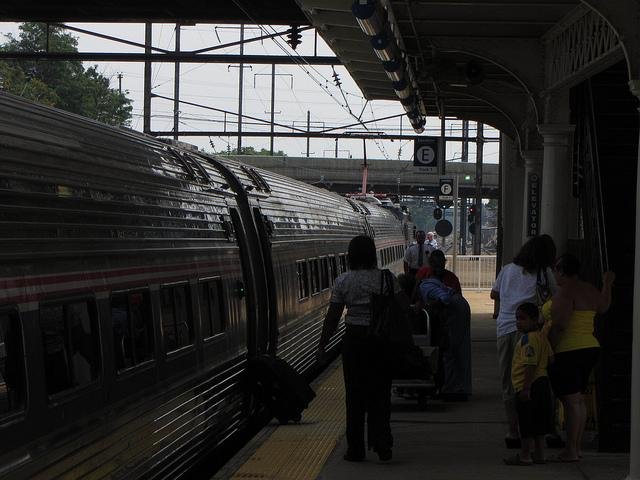What sort of power moves this vehicle? Please explain your reasoning. electric. You can see the power lines above it 